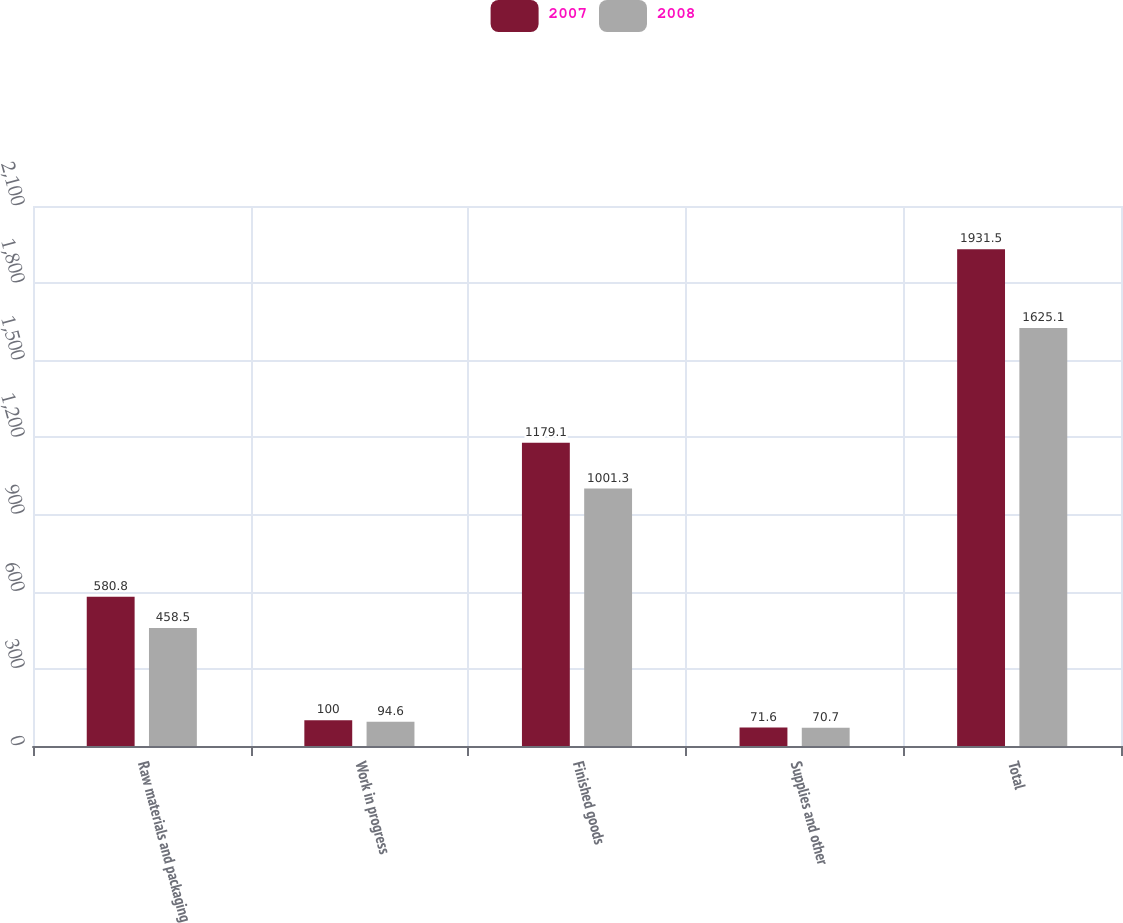Convert chart to OTSL. <chart><loc_0><loc_0><loc_500><loc_500><stacked_bar_chart><ecel><fcel>Raw materials and packaging<fcel>Work in progress<fcel>Finished goods<fcel>Supplies and other<fcel>Total<nl><fcel>2007<fcel>580.8<fcel>100<fcel>1179.1<fcel>71.6<fcel>1931.5<nl><fcel>2008<fcel>458.5<fcel>94.6<fcel>1001.3<fcel>70.7<fcel>1625.1<nl></chart> 